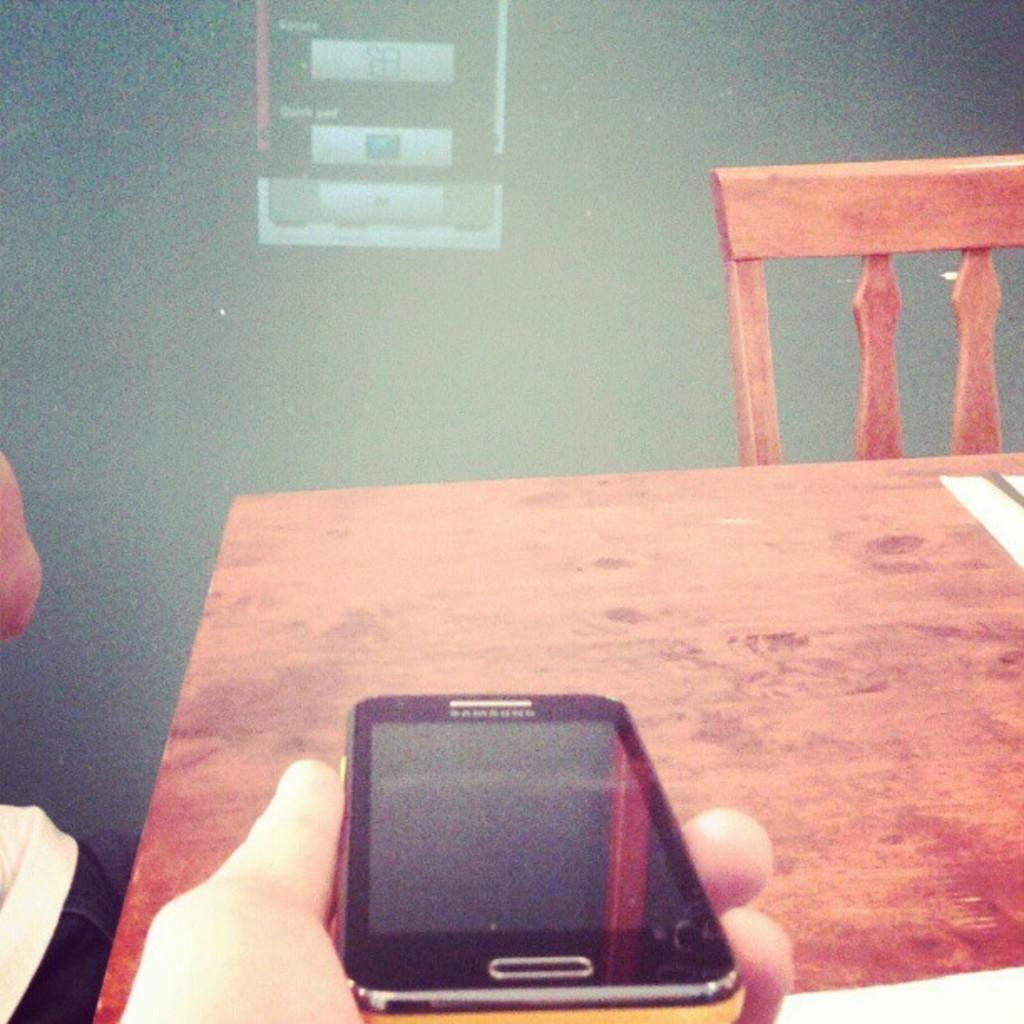What is the setting of the image? The image is taken in a room. Who or what is present in the image? There is a person in the image. What is the person holding in the image? The person is holding a Samsung mobile. What type of furniture is in the image? There is a wooden table and a chair in the image. What can be seen behind the table? There is a screen behind the table. What type of skirt is the cow wearing in the image? There is no cow or skirt present in the image. 